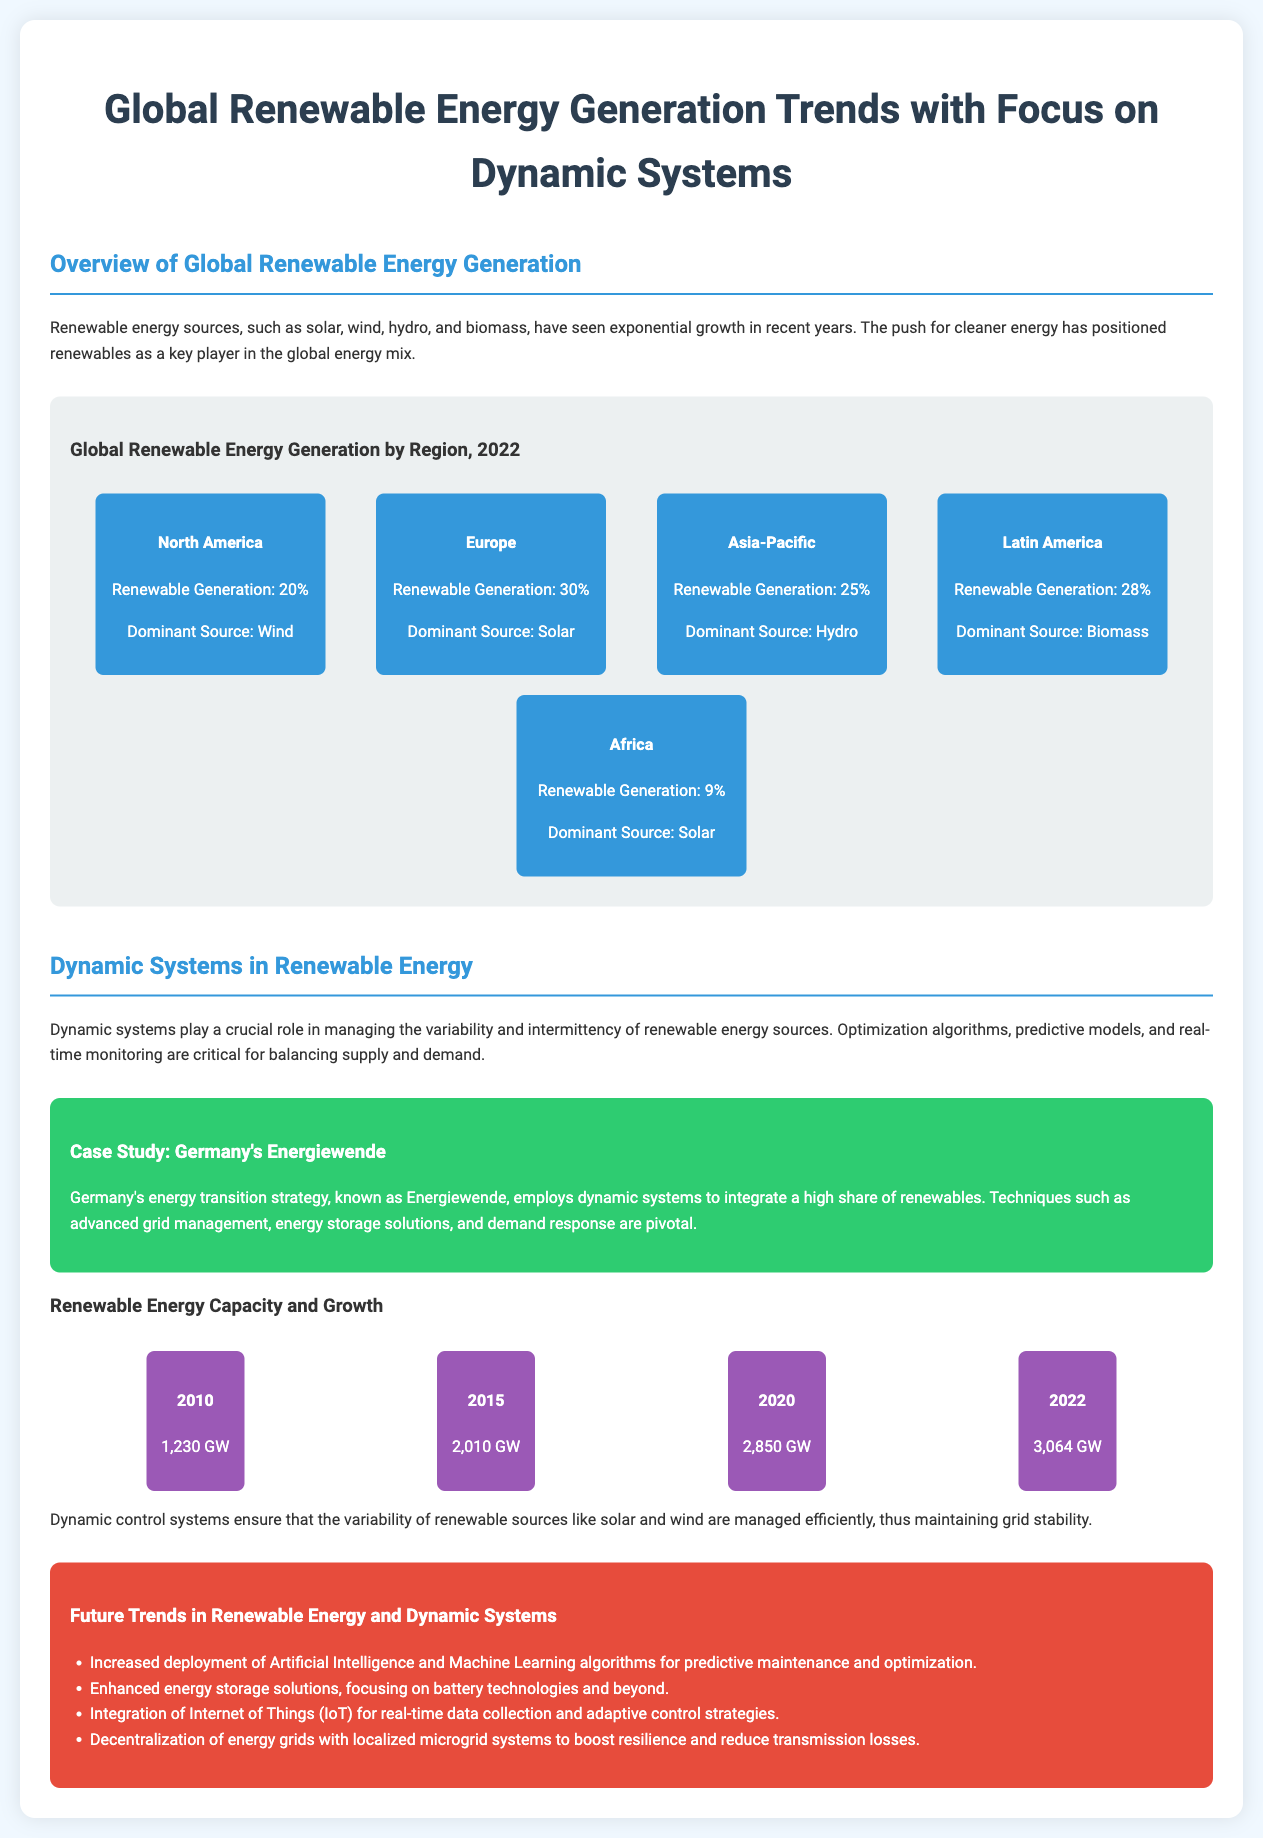What percentage of renewable generation comes from North America? The document states that the renewable generation in North America is represented as 20%.
Answer: 20% What is the dominant renewable energy source in Europe? According to the document, the dominant source of renewable energy in Europe is solar.
Answer: Solar What was the total renewable energy capacity in 2020? The document lists the renewable energy capacity for 2020 as 2,850 GW.
Answer: 2,850 GW What are the future trends mentioned in the document regarding renewable energy? The document outlines several future trends, including increased deployment of Artificial Intelligence and Machine Learning algorithms.
Answer: Increased deployment of Artificial Intelligence and Machine Learning algorithms for predictive maintenance and optimization What role do dynamic systems play in renewable energy? The document explains that dynamic systems are crucial for managing variability and intermittency of renewable energy sources.
Answer: Managing variability and intermittency What percentage of renewable generation does Africa represent? The document states that Africa has a renewable generation of 9%.
Answer: 9% What case study is highlighted in the document? The document specifically mentions Germany's Energiewende as a case study for integrating a high share of renewables.
Answer: Germany's Energiewende Which region has the highest percentage of renewable generation? According to the document, Europe has the highest renewable generation percentage at 30%.
Answer: Europe What techniques are pivotal in Germany's energy transition strategy? The document states that advanced grid management, energy storage solutions, and demand response are pivotal techniques used.
Answer: Advanced grid management, energy storage solutions, and demand response 